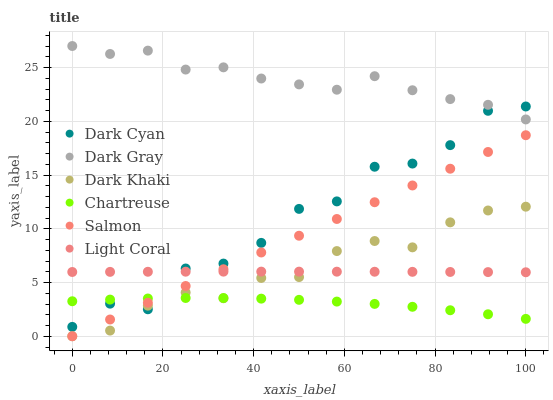Does Chartreuse have the minimum area under the curve?
Answer yes or no. Yes. Does Dark Gray have the maximum area under the curve?
Answer yes or no. Yes. Does Salmon have the minimum area under the curve?
Answer yes or no. No. Does Salmon have the maximum area under the curve?
Answer yes or no. No. Is Salmon the smoothest?
Answer yes or no. Yes. Is Dark Cyan the roughest?
Answer yes or no. Yes. Is Light Coral the smoothest?
Answer yes or no. No. Is Light Coral the roughest?
Answer yes or no. No. Does Dark Khaki have the lowest value?
Answer yes or no. Yes. Does Light Coral have the lowest value?
Answer yes or no. No. Does Dark Gray have the highest value?
Answer yes or no. Yes. Does Salmon have the highest value?
Answer yes or no. No. Is Chartreuse less than Dark Gray?
Answer yes or no. Yes. Is Dark Gray greater than Light Coral?
Answer yes or no. Yes. Does Dark Cyan intersect Light Coral?
Answer yes or no. Yes. Is Dark Cyan less than Light Coral?
Answer yes or no. No. Is Dark Cyan greater than Light Coral?
Answer yes or no. No. Does Chartreuse intersect Dark Gray?
Answer yes or no. No. 